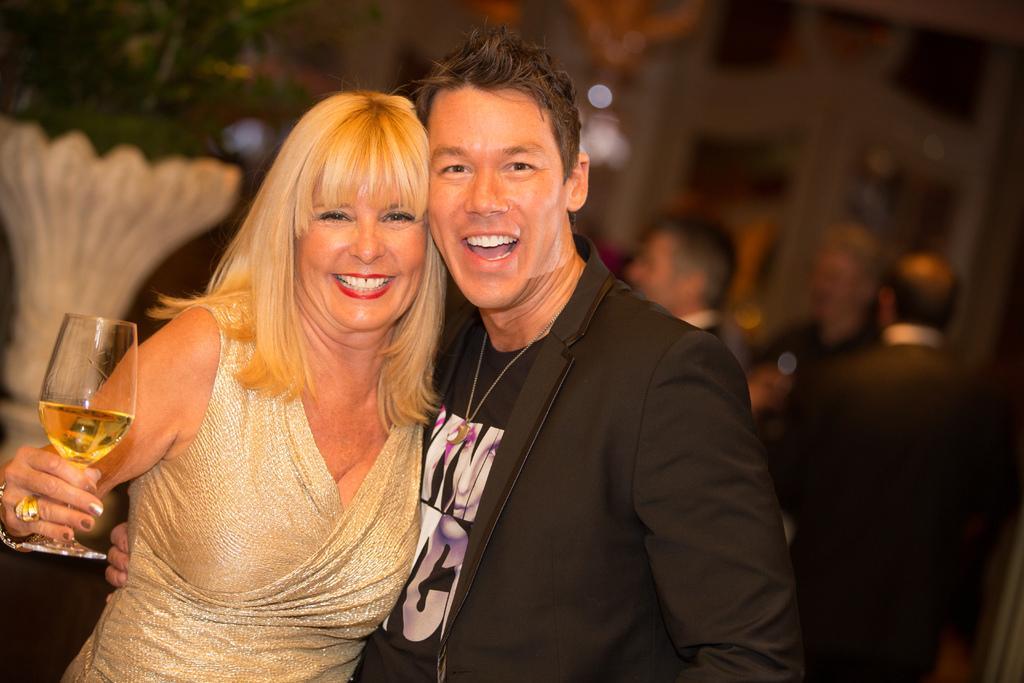Please provide a concise description of this image. In this picture we can see man and woman smiling where this man wore blazer and here woman holding glass with drink in it with her hands and in background it is blurry. 